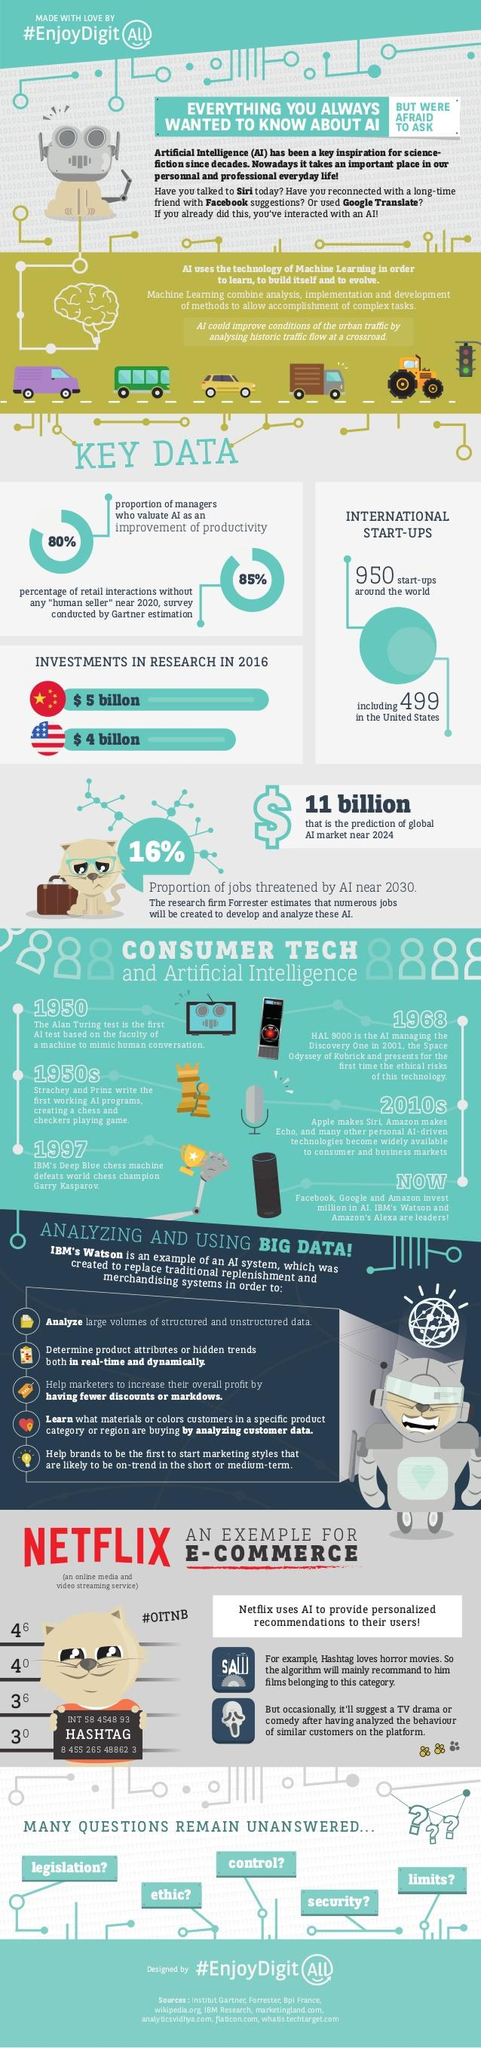Outline some significant characteristics in this image. IBM developed the Watson assistant. According to a survey of managers, 80% believe that the implementation of AI is necessary for improving productivity. In the 2010s, Siri and Echo, as well as many other AI-driven technologies, were made available to people. In 1997, IBM's Deep Blue chess machine defeated Garry Kasparov, a former world chess champion, through the use of advanced artificial intelligence. There are 5 uncertainties related to artificial intelligence mentioned in this text. 